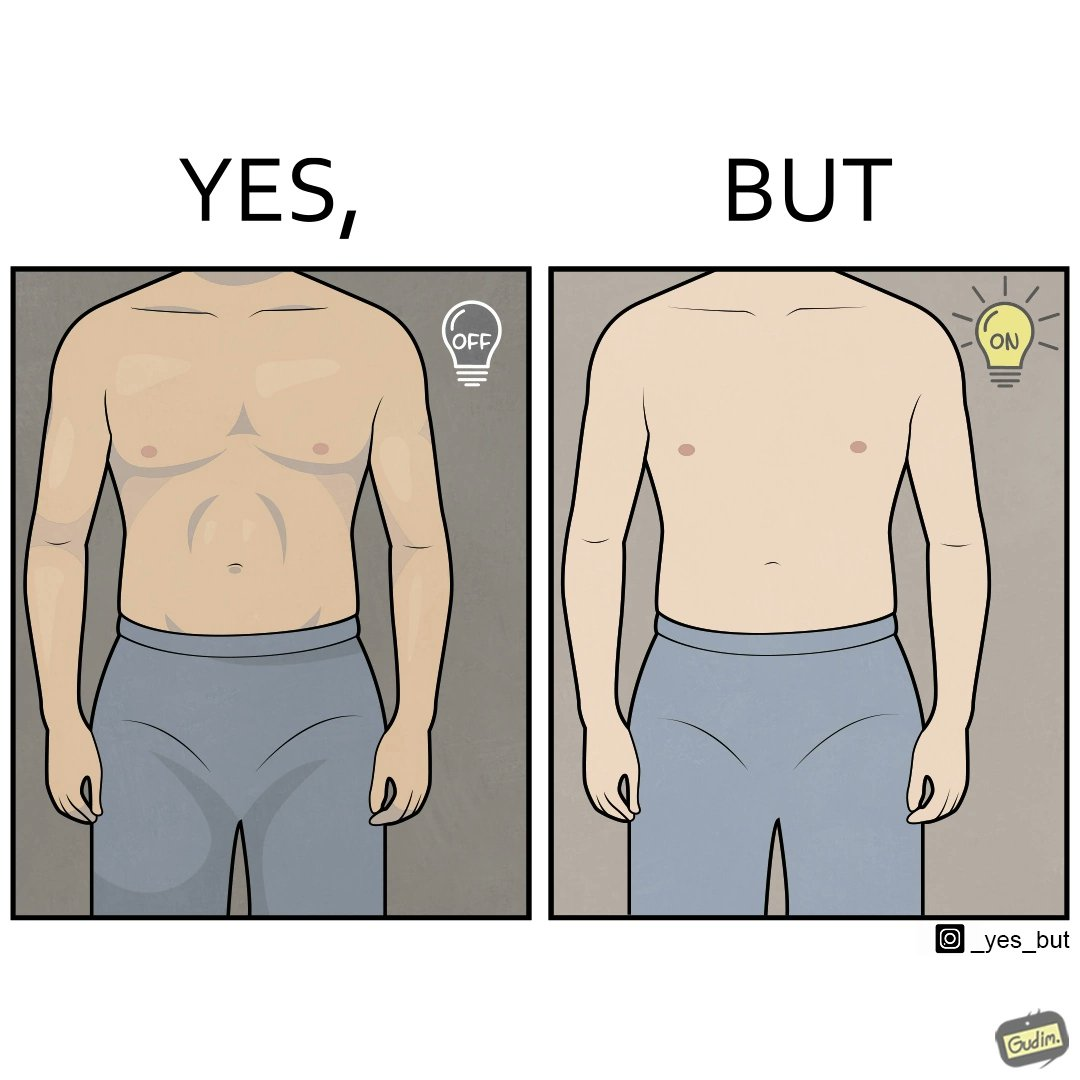Describe the satirical element in this image. The images are funny because it shows the same body in two different lighting conditions, one where it appears muscular and one where it does not appear so. It shows how we can make the same thing appear appealing to others without it being as appealing in real life 